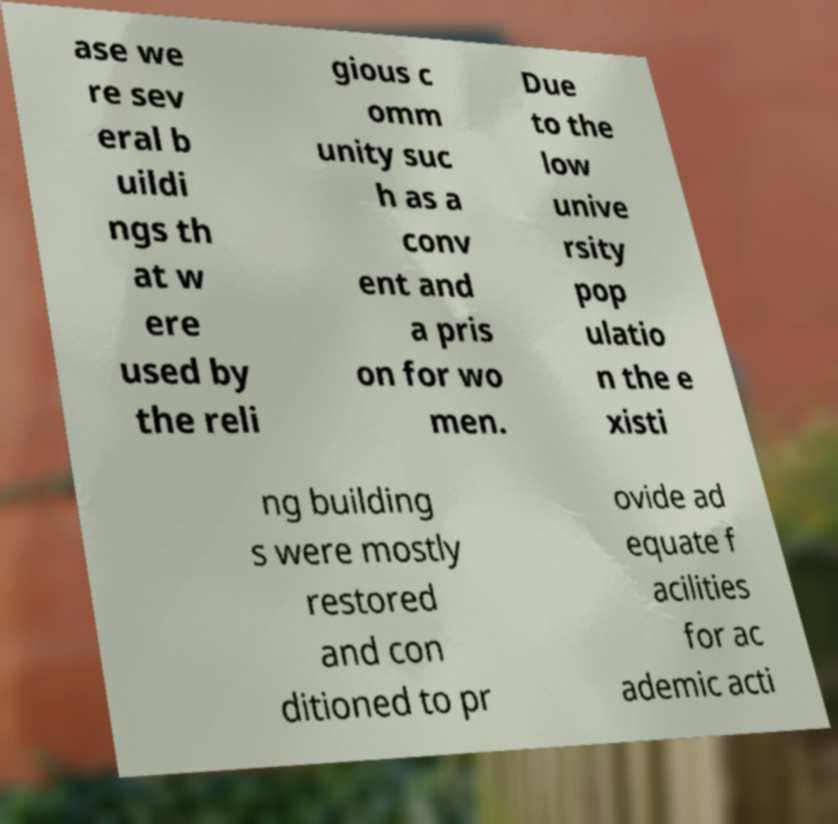Please read and relay the text visible in this image. What does it say? ase we re sev eral b uildi ngs th at w ere used by the reli gious c omm unity suc h as a conv ent and a pris on for wo men. Due to the low unive rsity pop ulatio n the e xisti ng building s were mostly restored and con ditioned to pr ovide ad equate f acilities for ac ademic acti 